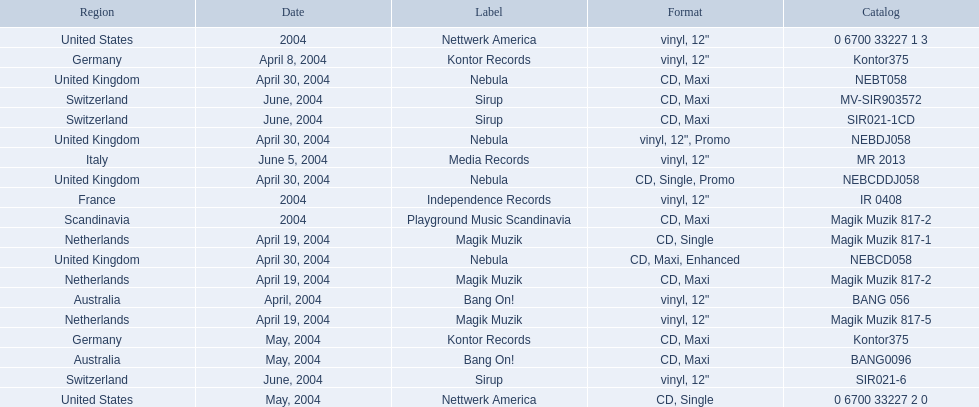What are all of the regions the title was released in? Netherlands, Netherlands, Netherlands, Germany, Germany, Australia, Australia, United Kingdom, United Kingdom, United Kingdom, United Kingdom, Switzerland, Switzerland, Switzerland, United States, United States, France, Italy, Scandinavia. And under which labels were they released? Magik Muzik, Magik Muzik, Magik Muzik, Kontor Records, Kontor Records, Bang On!, Bang On!, Nebula, Nebula, Nebula, Nebula, Sirup, Sirup, Sirup, Nettwerk America, Nettwerk America, Independence Records, Media Records, Playground Music Scandinavia. Which label released the song in france? Independence Records. 